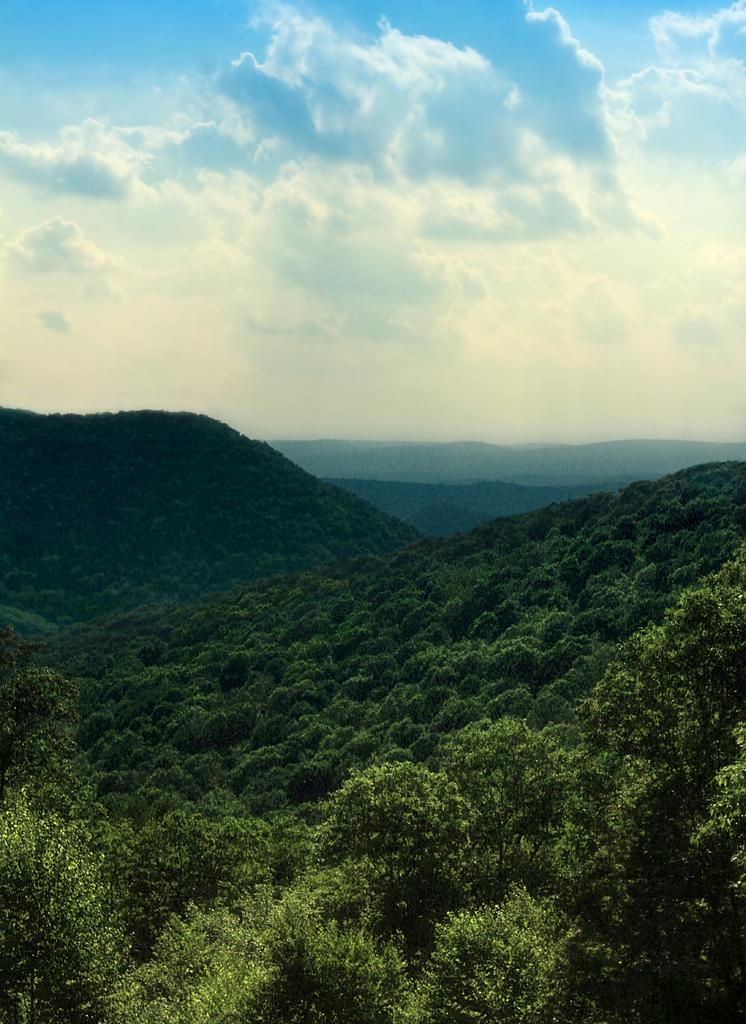What type of natural formation can be seen in the image? There are mountains in the image. What covers the mountains in the image? The mountains are covered with trees. What is the condition of the sky in the image? The sky is clear in the image. What word is written on the side of the mountain in the image? There are no words visible on the mountains in the image. Can you see a home or any other type of building in the image? There are no homes or buildings visible in the image; it only features mountains and trees. 